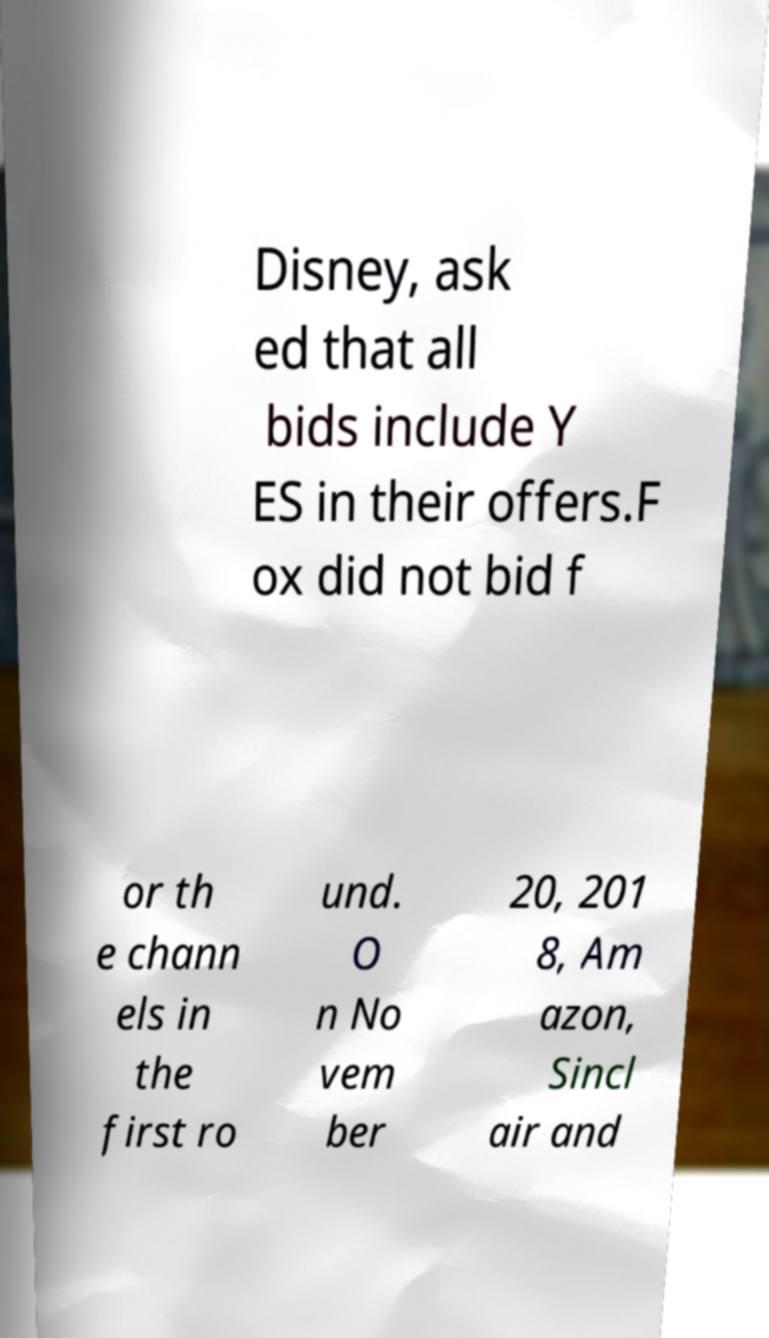There's text embedded in this image that I need extracted. Can you transcribe it verbatim? Disney, ask ed that all bids include Y ES in their offers.F ox did not bid f or th e chann els in the first ro und. O n No vem ber 20, 201 8, Am azon, Sincl air and 